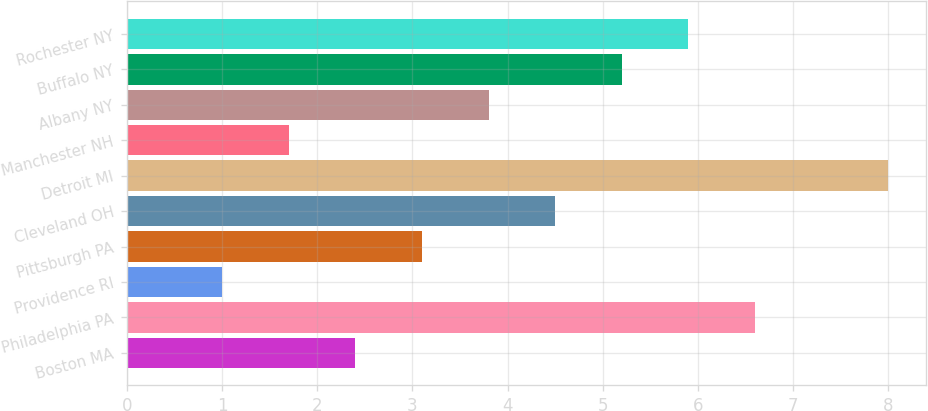<chart> <loc_0><loc_0><loc_500><loc_500><bar_chart><fcel>Boston MA<fcel>Philadelphia PA<fcel>Providence RI<fcel>Pittsburgh PA<fcel>Cleveland OH<fcel>Detroit MI<fcel>Manchester NH<fcel>Albany NY<fcel>Buffalo NY<fcel>Rochester NY<nl><fcel>2.4<fcel>6.6<fcel>1<fcel>3.1<fcel>4.5<fcel>8<fcel>1.7<fcel>3.8<fcel>5.2<fcel>5.9<nl></chart> 